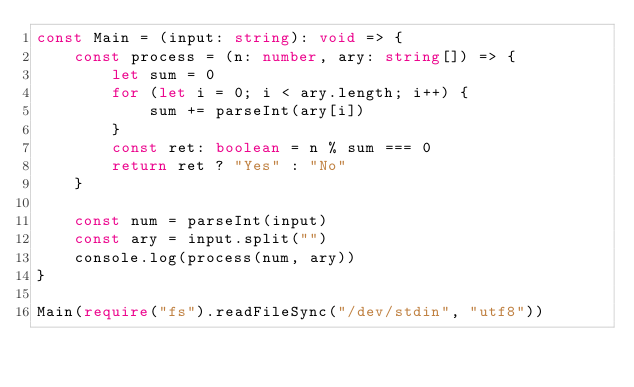Convert code to text. <code><loc_0><loc_0><loc_500><loc_500><_TypeScript_>const Main = (input: string): void => {
	const process = (n: number, ary: string[]) => {
		let sum = 0
		for (let i = 0; i < ary.length; i++) {
			sum += parseInt(ary[i])
		}
		const ret: boolean = n % sum === 0
		return ret ? "Yes" : "No"
	}

	const num = parseInt(input)
	const ary = input.split("")
	console.log(process(num, ary))
}

Main(require("fs").readFileSync("/dev/stdin", "utf8"))</code> 